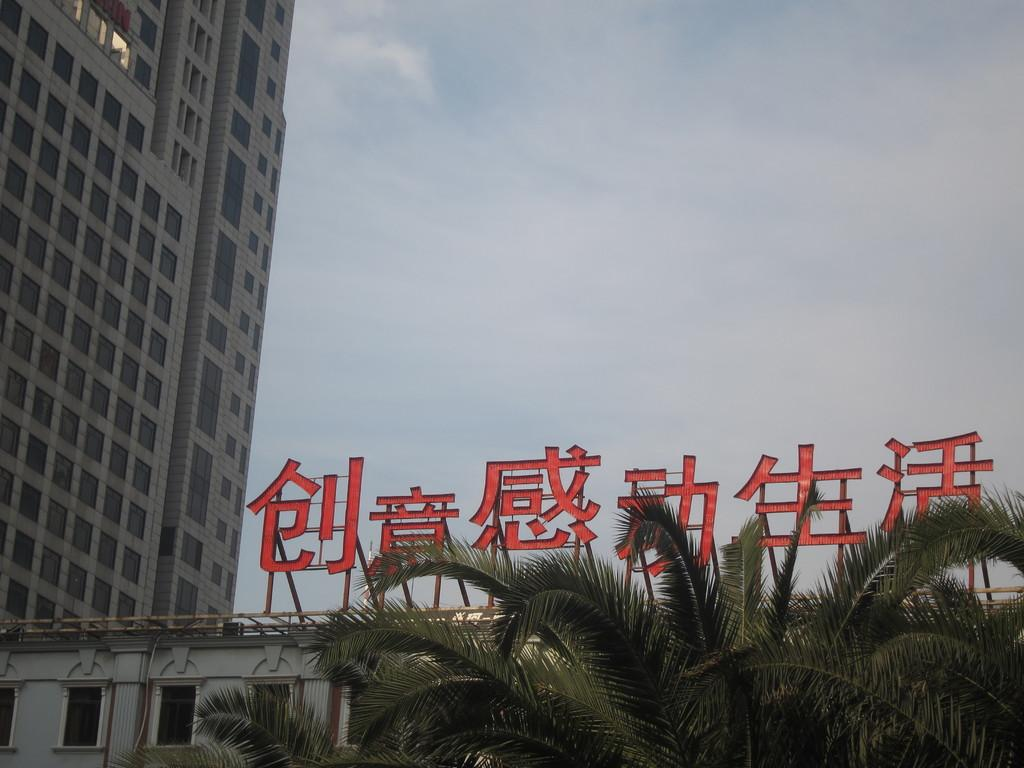What type of structures are present in the image? There are buildings with windows in the image. What else can be seen on the buildings? There are poles on the buildings. What is written or displayed in the image? There is text visible in the image. What type of natural elements are present in the image? There are trees in the image. What is visible in the background of the image? The sky is visible in the image, and clouds are present in the sky. What type of oil is being used by the queen in the image? There is no queen or oil present in the image. How many thumbs can be seen on the buildings in the image? Thumbs are not visible on the buildings in the image. 